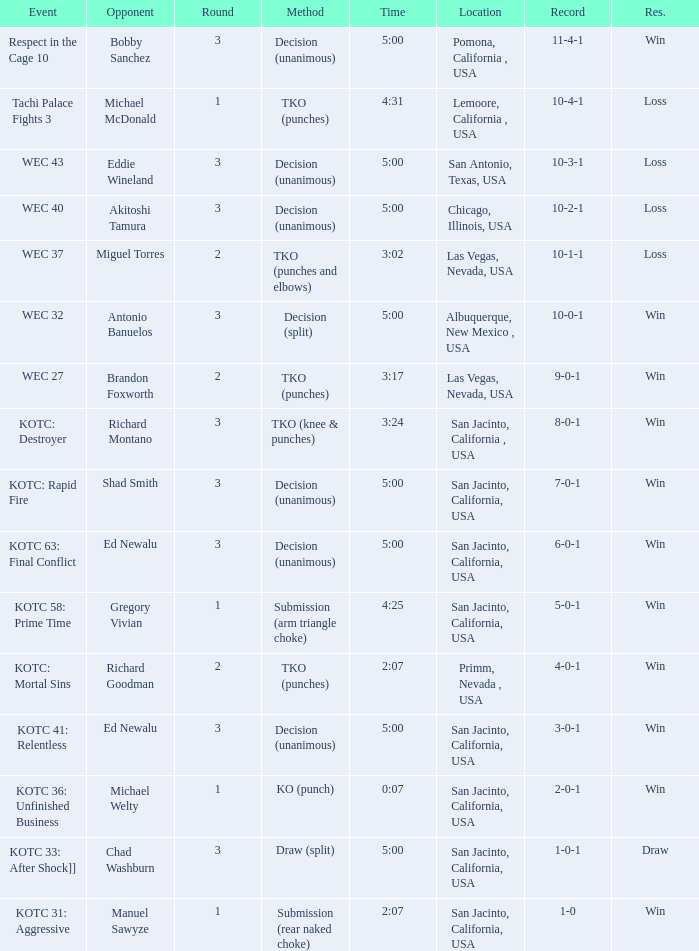What time did the even tachi palace fights 3 take place? 4:31. 